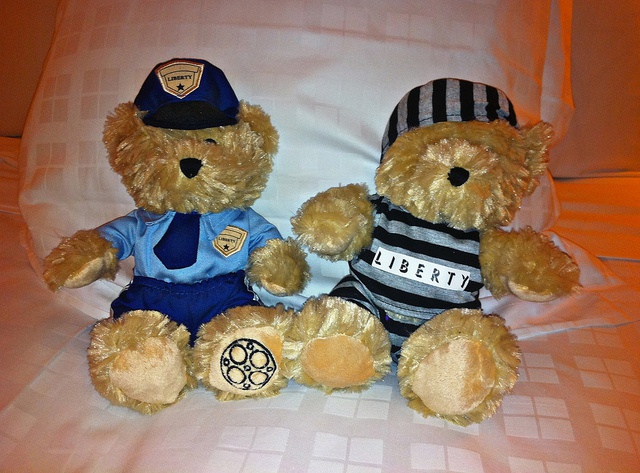Describe the objects in this image and their specific colors. I can see bed in gray, darkgray, brown, tan, and maroon tones, teddy bear in maroon, tan, olive, black, and gray tones, teddy bear in maroon, tan, black, and olive tones, and tie in maroon, navy, and blue tones in this image. 